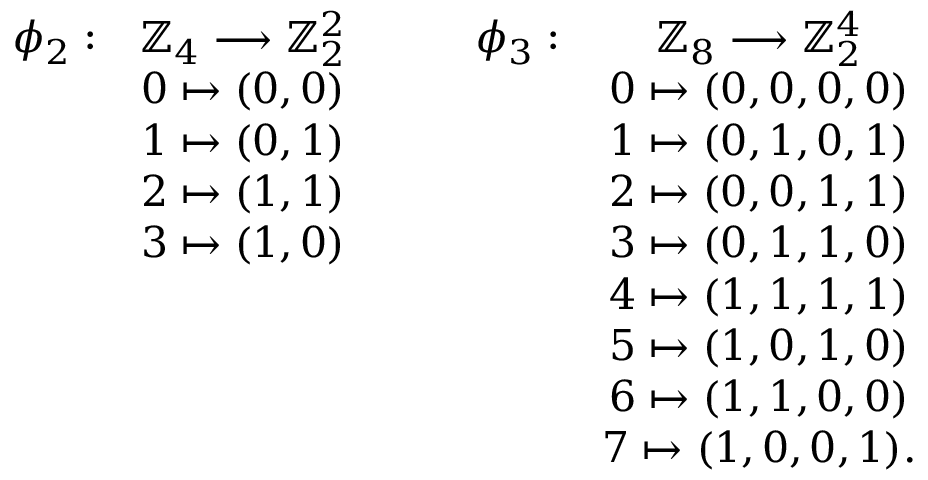<formula> <loc_0><loc_0><loc_500><loc_500>\begin{array} { c c c c c c c c c l } { \phi _ { 2 } \colon } & { \mathbb { Z } _ { 4 } \longrightarrow \mathbb { Z } _ { 2 } ^ { 2 } } & & & { \phi _ { 3 } \colon } & { \mathbb { Z } _ { 8 } \longrightarrow \mathbb { Z } _ { 2 } ^ { 4 } } \\ & { 0 \mapsto ( 0 , 0 ) } & & & & { 0 \mapsto ( 0 , 0 , 0 , 0 ) } \\ & { 1 \mapsto ( 0 , 1 ) } & & & & { 1 \mapsto ( 0 , 1 , 0 , 1 ) } \\ & { 2 \mapsto ( 1 , 1 ) } & & & & { 2 \mapsto ( 0 , 0 , 1 , 1 ) } \\ & { 3 \mapsto ( 1 , 0 ) } & & & & { 3 \mapsto ( 0 , 1 , 1 , 0 ) } \\ & & & & & { 4 \mapsto ( 1 , 1 , 1 , 1 ) } \\ & & & & & { 5 \mapsto ( 1 , 0 , 1 , 0 ) } \\ & & & & & { 6 \mapsto ( 1 , 1 , 0 , 0 ) } \\ & & & & & { 7 \mapsto ( 1 , 0 , 0 , 1 ) . } \end{array}</formula> 